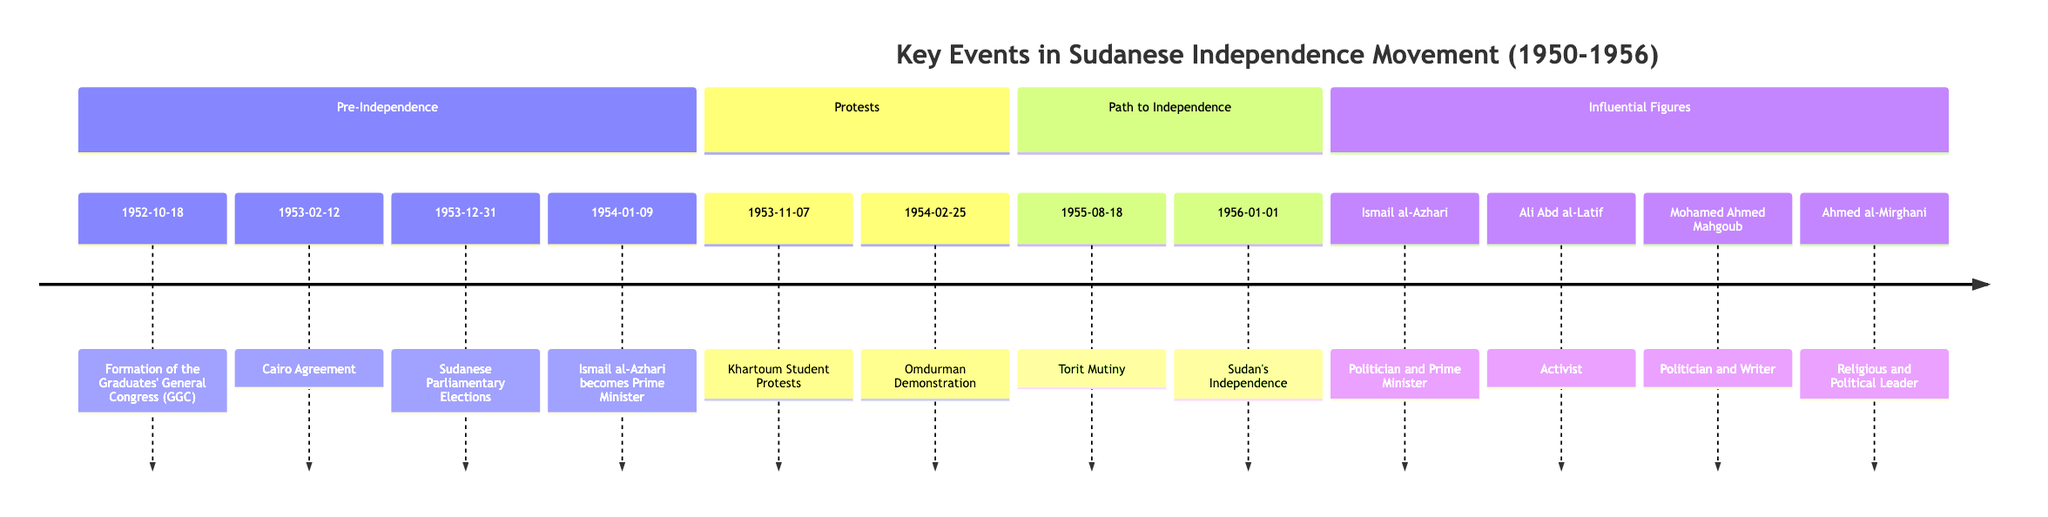What event marked the formation of the Graduates' General Congress? The diagram specifies that the Graduates' General Congress was formed on 1952-10-18. This date is associated explicitly with this event in the first section of the timeline.
Answer: Formation of the Graduates' General Congress (GGC) How many significant protests are listed in the timeline? The timeline indicates that there are two major protests recorded: the Khartoum Student Protests on 1953-11-07 and the Omdurman Demonstration on 1954-02-25. This count is directly derived from the Protests section in the diagram.
Answer: 2 Who became Prime Minister after the Sudanese Parliamentary Elections? According to the timeline, after the Sudanese Parliamentary Elections on 1953-12-31, Ismail al-Azhari was elected as Prime Minister, as indicated in the timeline.
Answer: Ismail al-Azhari What date did Sudan officially gain independence? The timeline clearly states that Sudan gained its independence on 1956-01-01, indicated in the Path to Independence section of the diagram.
Answer: 1956-01-01 What was the primary purpose of the Graduates' General Congress when it was formed? The timeline reveals that the initial purpose of the GGC was to address educational and social issues, which then evolved into a political platform for advocating for Sudanese independence. This understanding is derived from the description associated with its formation in the timeline.
Answer: Address educational and social issues Which influential figure was a key activist in the early nationalist movement? The diagram highlights Ali Abd al-Latif as a key figure in the early nationalist movement and co-founder of the White Flag League, showing his significant contribution to pushing for self-determination.
Answer: Ali Abd al-Latif How did the Cairo Agreement contribute to Sudan's path to independence? The Cairo Agreement established a three-year transitional period for Sudan leading to self-governance and eventual independence, according to the event description in the timeline. This implies a direct link between the agreement and the progression towards independence.
Answer: Three-year transitional period What event indicated rising tensions among Southern Sudanese soldiers? The timeline notes that the Torit Mutiny on 1955-08-18 marked rising tensions and dissatisfaction among Southern Sudanese soldiers, clearly establishing it as a foreshadowing of later conflicts.
Answer: Torit Mutiny 